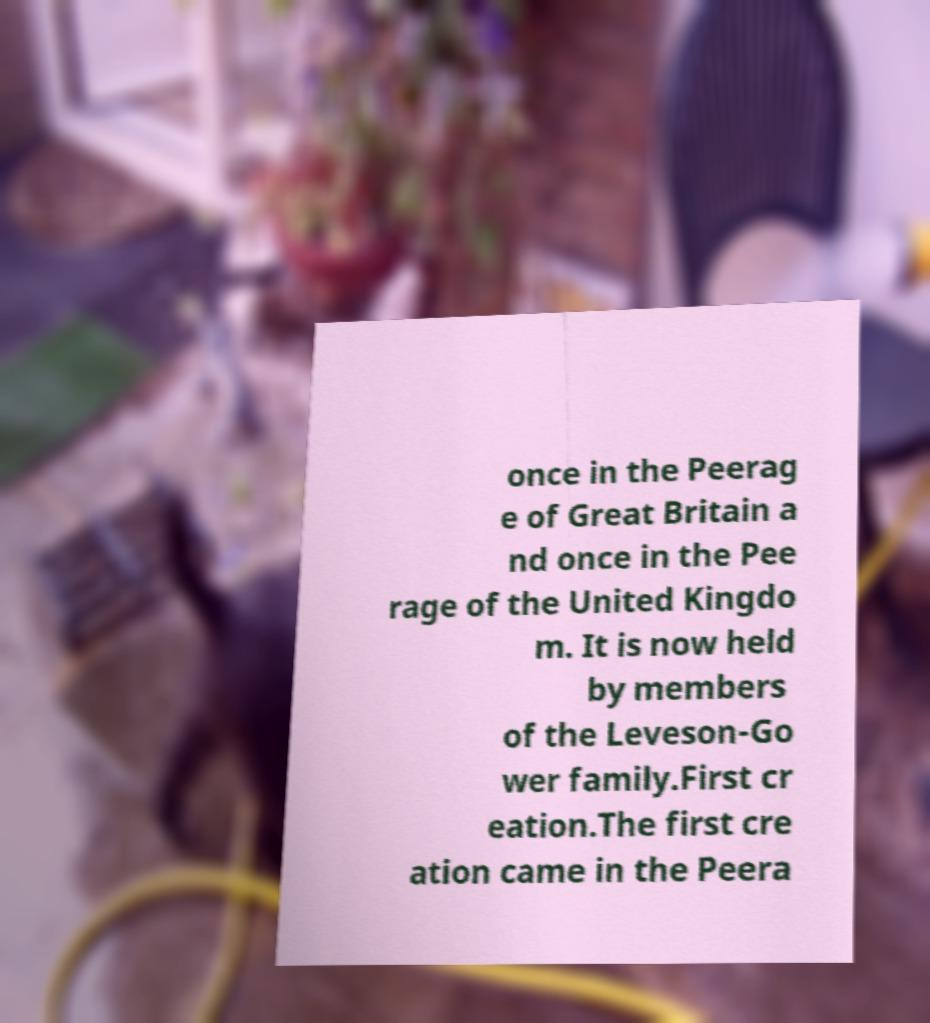Could you extract and type out the text from this image? once in the Peerag e of Great Britain a nd once in the Pee rage of the United Kingdo m. It is now held by members of the Leveson-Go wer family.First cr eation.The first cre ation came in the Peera 